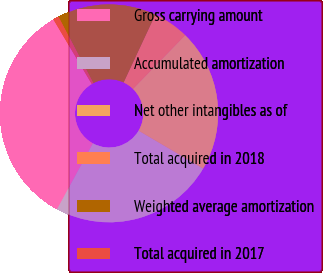Convert chart. <chart><loc_0><loc_0><loc_500><loc_500><pie_chart><fcel>Gross carrying amount<fcel>Accumulated amortization<fcel>Net other intangibles as of<fcel>Total acquired in 2018<fcel>Weighted average amortization<fcel>Total acquired in 2017<nl><fcel>33.55%<fcel>24.46%<fcel>21.19%<fcel>5.31%<fcel>14.65%<fcel>0.85%<nl></chart> 